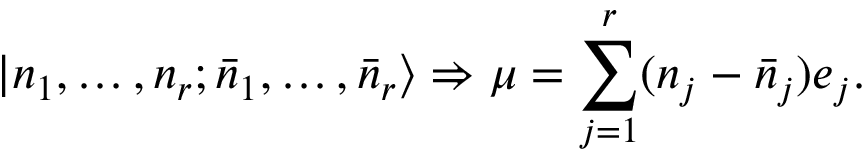Convert formula to latex. <formula><loc_0><loc_0><loc_500><loc_500>| n _ { 1 } , \dots , n _ { r } ; \bar { n } _ { 1 } , \dots , \bar { n } _ { r } \rangle \Rightarrow \mu = \sum _ { j = 1 } ^ { r } ( n _ { j } - \bar { n } _ { j } ) e _ { j } .</formula> 